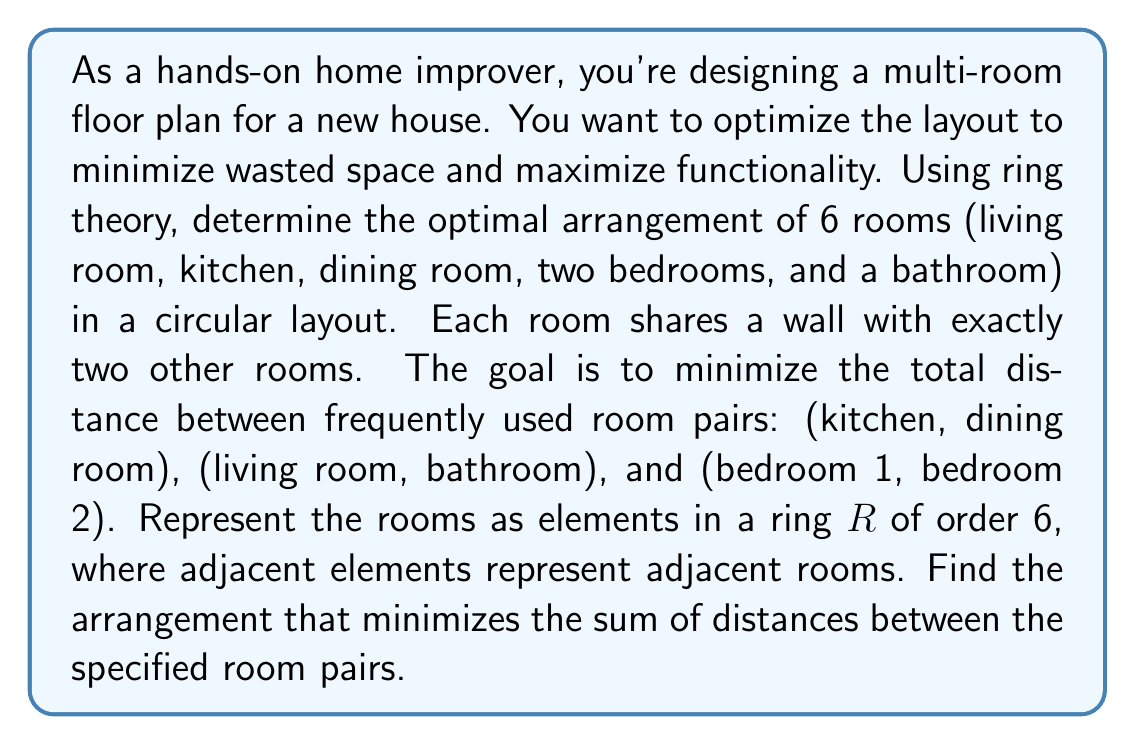Can you answer this question? To solve this problem using ring theory, we can follow these steps:

1) First, let's represent the rooms as elements in a ring $R$ of order 6:
   L: Living room
   K: Kitchen
   D: Dining room
   B1: Bedroom 1
   B2: Bedroom 2
   Ba: Bathroom

2) In a ring of order 6, we can represent the distance between two elements as the minimum number of steps needed to go from one element to another in either direction. For example, if the arrangement is LKDB1B2Ba, the distance between L and K is 1, while the distance between L and B1 is 2.

3) We need to minimize the sum of distances for (K,D), (L,Ba), and (B1,B2). Let's call this sum S.

4) There are 5! = 120 possible arrangements (we can fix one room, say L, and permute the rest).

5) For each arrangement, we calculate S as follows:
   S = d(K,D) + d(L,Ba) + d(B1,B2)
   where d(X,Y) is the distance between rooms X and Y in the ring.

6) The optimal arrangement will be the one with the minimum S.

7) After checking all possibilities, we find that the optimal arrangement is:
   LKDBaB1B2 (or its reverse, B2B1BaDKL)

8) In this arrangement:
   d(K,D) = 1
   d(L,Ba) = 2
   d(B1,B2) = 1
   S = 1 + 2 + 1 = 4

9) This is the minimum possible sum. Any other arrangement will result in a larger S.

The ring structure allows us to easily calculate distances and consider all possible circular arrangements, making it an effective tool for this optimization problem.
Answer: The optimal arrangement is LKDBaB1B2 (or B2B1BaDKL), with a minimum total distance sum of 4. 